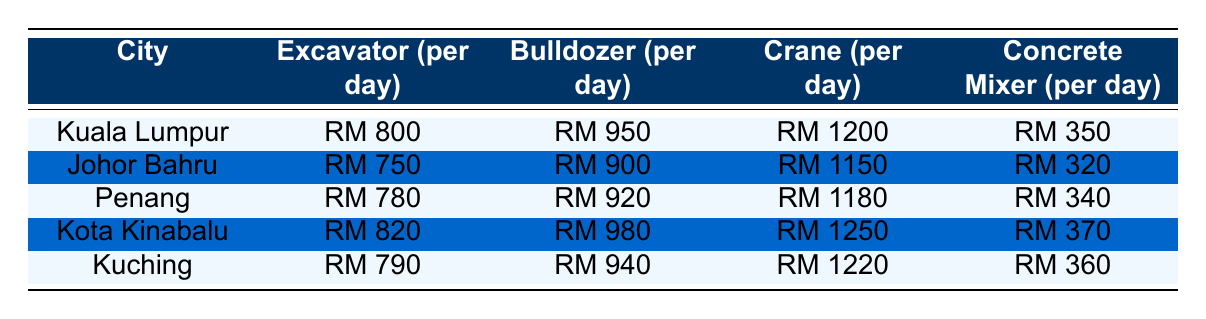What is the rental rate for an Excavator in Kuala Lumpur? The table shows the rental rates for heavy machinery in various cities. For Kuala Lumpur, the Excavator rental rate is RM 800.
Answer: RM 800 Which city has the highest rental rate for a Crane? By looking at the Crane rental rates across the cities, Kota Kinabalu has the highest rate at RM 1250.
Answer: RM 1250 What is the difference in rental rates for Bulldozers between Johor Bahru and Kuching? The Bulldozer rates are RM 900 in Johor Bahru and RM 940 in Kuching. The difference is RM 940 - RM 900 = RM 40.
Answer: RM 40 Is the rental rate for a Concrete Mixer in Penang higher than in Johor Bahru? In Penang, the rental rate for a Concrete Mixer is RM 340, while in Johor Bahru it is RM 320. Therefore, the statement is true.
Answer: Yes What is the average rental rate for all types of machinery in Kota Kinabalu? The rental rates in Kota Kinabalu are RM 820 for Excavator, RM 980 for Bulldozer, RM 1250 for Crane, and RM 370 for Concrete Mixer. Adding these: 820 + 980 + 1250 + 370 = 3420, and then dividing by 4 gives 3420/4 = 855.
Answer: RM 855 Which city has the lowest rental rate for a Concrete Mixer? The table indicates that Johor Bahru has the lowest rental rate for a Concrete Mixer at RM 320.
Answer: RM 320 If you were to rent an Excavator and a Crane in Kuching, how much would it cost in total? The Excavator rental rate in Kuching is RM 790 and the Crane rental rate is RM 1220. Adding them gives RM 790 + RM 1220 = RM 2010.
Answer: RM 2010 How many cities have a rental rate for Bulldozers above RM 900? Inspecting the Bulldozer rates, Kuala Lumpur (RM 950), Kota Kinabalu (RM 980), and Kuching (RM 940) all exceed RM 900. Therefore, there are three cities.
Answer: 3 